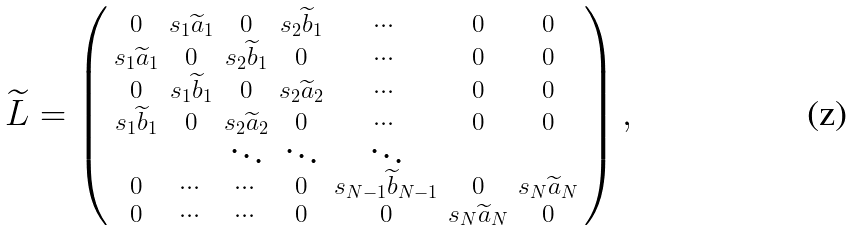Convert formula to latex. <formula><loc_0><loc_0><loc_500><loc_500>\widetilde { L } = \left ( \begin{smallmatrix} 0 & s _ { 1 } \widetilde { a } _ { 1 } & 0 & s _ { 2 } \widetilde { b } _ { 1 } & \cdots & 0 & 0 \\ s _ { 1 } \widetilde { a } _ { 1 } & 0 & s _ { 2 } \widetilde { b } _ { 1 } & 0 & \cdots & 0 & 0 \\ 0 & s _ { 1 } \widetilde { b } _ { 1 } & 0 & s _ { 2 } \widetilde { a } _ { 2 } & \cdots & 0 & 0 \\ s _ { 1 } \widetilde { b } _ { 1 } & 0 & s _ { 2 } \widetilde { a } _ { 2 } & 0 & \cdots & 0 & 0 \\ & & \ddots & \ddots & \ddots & \\ 0 & \cdots & \cdots & 0 & s _ { N - 1 } \widetilde { b } _ { N - 1 } & 0 & s _ { N } \widetilde { a } _ { N } \\ 0 & \cdots & \cdots & 0 & 0 & s _ { N } \widetilde { a } _ { N } & 0 \\ \end{smallmatrix} \right ) ,</formula> 